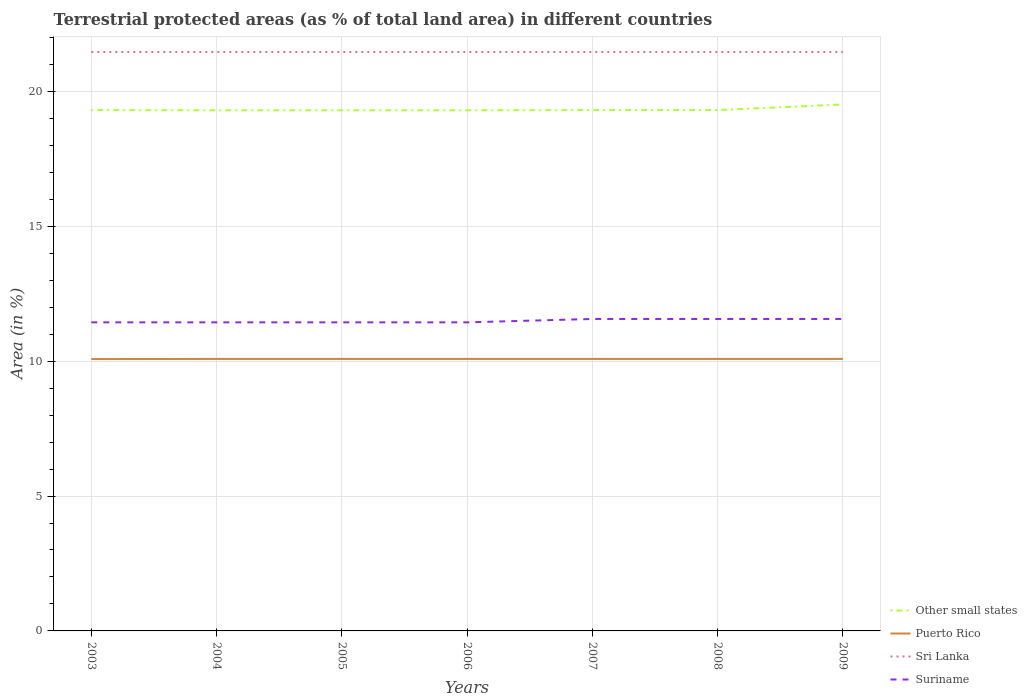How many different coloured lines are there?
Give a very brief answer. 4. Does the line corresponding to Sri Lanka intersect with the line corresponding to Other small states?
Make the answer very short. No. Across all years, what is the maximum percentage of terrestrial protected land in Suriname?
Your response must be concise. 11.44. What is the difference between the highest and the second highest percentage of terrestrial protected land in Sri Lanka?
Ensure brevity in your answer.  0. What is the difference between the highest and the lowest percentage of terrestrial protected land in Puerto Rico?
Offer a very short reply. 6. How many lines are there?
Ensure brevity in your answer.  4. What is the difference between two consecutive major ticks on the Y-axis?
Offer a very short reply. 5. Are the values on the major ticks of Y-axis written in scientific E-notation?
Ensure brevity in your answer.  No. How are the legend labels stacked?
Give a very brief answer. Vertical. What is the title of the graph?
Provide a succinct answer. Terrestrial protected areas (as % of total land area) in different countries. Does "Australia" appear as one of the legend labels in the graph?
Give a very brief answer. No. What is the label or title of the X-axis?
Offer a terse response. Years. What is the label or title of the Y-axis?
Offer a terse response. Area (in %). What is the Area (in %) of Other small states in 2003?
Your answer should be very brief. 19.31. What is the Area (in %) in Puerto Rico in 2003?
Ensure brevity in your answer.  10.08. What is the Area (in %) of Sri Lanka in 2003?
Give a very brief answer. 21.46. What is the Area (in %) in Suriname in 2003?
Provide a short and direct response. 11.44. What is the Area (in %) of Other small states in 2004?
Your answer should be very brief. 19.3. What is the Area (in %) in Puerto Rico in 2004?
Your answer should be compact. 10.08. What is the Area (in %) of Sri Lanka in 2004?
Offer a terse response. 21.46. What is the Area (in %) in Suriname in 2004?
Offer a terse response. 11.44. What is the Area (in %) in Other small states in 2005?
Offer a terse response. 19.3. What is the Area (in %) in Puerto Rico in 2005?
Your answer should be compact. 10.08. What is the Area (in %) of Sri Lanka in 2005?
Make the answer very short. 21.46. What is the Area (in %) of Suriname in 2005?
Your response must be concise. 11.44. What is the Area (in %) of Other small states in 2006?
Your answer should be very brief. 19.3. What is the Area (in %) of Puerto Rico in 2006?
Provide a succinct answer. 10.08. What is the Area (in %) of Sri Lanka in 2006?
Your response must be concise. 21.46. What is the Area (in %) in Suriname in 2006?
Your answer should be compact. 11.44. What is the Area (in %) in Other small states in 2007?
Your answer should be compact. 19.31. What is the Area (in %) of Puerto Rico in 2007?
Provide a short and direct response. 10.08. What is the Area (in %) in Sri Lanka in 2007?
Your answer should be very brief. 21.46. What is the Area (in %) of Suriname in 2007?
Provide a short and direct response. 11.56. What is the Area (in %) of Other small states in 2008?
Your response must be concise. 19.31. What is the Area (in %) of Puerto Rico in 2008?
Provide a short and direct response. 10.08. What is the Area (in %) of Sri Lanka in 2008?
Offer a terse response. 21.46. What is the Area (in %) of Suriname in 2008?
Provide a succinct answer. 11.56. What is the Area (in %) of Other small states in 2009?
Provide a short and direct response. 19.52. What is the Area (in %) of Puerto Rico in 2009?
Your answer should be compact. 10.08. What is the Area (in %) in Sri Lanka in 2009?
Give a very brief answer. 21.46. What is the Area (in %) in Suriname in 2009?
Offer a terse response. 11.56. Across all years, what is the maximum Area (in %) of Other small states?
Your answer should be compact. 19.52. Across all years, what is the maximum Area (in %) of Puerto Rico?
Your answer should be very brief. 10.08. Across all years, what is the maximum Area (in %) in Sri Lanka?
Keep it short and to the point. 21.46. Across all years, what is the maximum Area (in %) in Suriname?
Make the answer very short. 11.56. Across all years, what is the minimum Area (in %) of Other small states?
Your answer should be compact. 19.3. Across all years, what is the minimum Area (in %) of Puerto Rico?
Give a very brief answer. 10.08. Across all years, what is the minimum Area (in %) of Sri Lanka?
Your answer should be very brief. 21.46. Across all years, what is the minimum Area (in %) of Suriname?
Ensure brevity in your answer.  11.44. What is the total Area (in %) of Other small states in the graph?
Make the answer very short. 135.35. What is the total Area (in %) in Puerto Rico in the graph?
Your answer should be very brief. 70.58. What is the total Area (in %) in Sri Lanka in the graph?
Give a very brief answer. 150.25. What is the total Area (in %) in Suriname in the graph?
Provide a succinct answer. 80.45. What is the difference between the Area (in %) of Other small states in 2003 and that in 2004?
Keep it short and to the point. 0.01. What is the difference between the Area (in %) of Puerto Rico in 2003 and that in 2004?
Provide a succinct answer. -0.01. What is the difference between the Area (in %) in Other small states in 2003 and that in 2005?
Your answer should be very brief. 0.01. What is the difference between the Area (in %) of Puerto Rico in 2003 and that in 2005?
Ensure brevity in your answer.  -0.01. What is the difference between the Area (in %) in Sri Lanka in 2003 and that in 2005?
Provide a succinct answer. 0. What is the difference between the Area (in %) of Other small states in 2003 and that in 2006?
Your answer should be compact. 0.01. What is the difference between the Area (in %) in Puerto Rico in 2003 and that in 2006?
Ensure brevity in your answer.  -0.01. What is the difference between the Area (in %) in Suriname in 2003 and that in 2006?
Keep it short and to the point. 0. What is the difference between the Area (in %) of Other small states in 2003 and that in 2007?
Make the answer very short. 0. What is the difference between the Area (in %) of Puerto Rico in 2003 and that in 2007?
Offer a terse response. -0.01. What is the difference between the Area (in %) of Sri Lanka in 2003 and that in 2007?
Offer a terse response. 0. What is the difference between the Area (in %) of Suriname in 2003 and that in 2007?
Keep it short and to the point. -0.13. What is the difference between the Area (in %) of Other small states in 2003 and that in 2008?
Ensure brevity in your answer.  0. What is the difference between the Area (in %) in Puerto Rico in 2003 and that in 2008?
Offer a terse response. -0.01. What is the difference between the Area (in %) in Sri Lanka in 2003 and that in 2008?
Your answer should be very brief. 0. What is the difference between the Area (in %) of Suriname in 2003 and that in 2008?
Provide a succinct answer. -0.13. What is the difference between the Area (in %) in Other small states in 2003 and that in 2009?
Your response must be concise. -0.21. What is the difference between the Area (in %) in Puerto Rico in 2003 and that in 2009?
Offer a terse response. -0.01. What is the difference between the Area (in %) of Sri Lanka in 2003 and that in 2009?
Offer a very short reply. 0. What is the difference between the Area (in %) of Suriname in 2003 and that in 2009?
Offer a terse response. -0.13. What is the difference between the Area (in %) of Other small states in 2004 and that in 2005?
Ensure brevity in your answer.  -0. What is the difference between the Area (in %) in Sri Lanka in 2004 and that in 2005?
Provide a short and direct response. 0. What is the difference between the Area (in %) of Other small states in 2004 and that in 2006?
Provide a succinct answer. -0. What is the difference between the Area (in %) of Puerto Rico in 2004 and that in 2006?
Your answer should be compact. 0. What is the difference between the Area (in %) in Other small states in 2004 and that in 2007?
Make the answer very short. -0.01. What is the difference between the Area (in %) of Puerto Rico in 2004 and that in 2007?
Your response must be concise. 0. What is the difference between the Area (in %) in Sri Lanka in 2004 and that in 2007?
Provide a succinct answer. 0. What is the difference between the Area (in %) of Suriname in 2004 and that in 2007?
Make the answer very short. -0.13. What is the difference between the Area (in %) in Other small states in 2004 and that in 2008?
Offer a very short reply. -0.01. What is the difference between the Area (in %) in Puerto Rico in 2004 and that in 2008?
Your answer should be compact. 0. What is the difference between the Area (in %) in Sri Lanka in 2004 and that in 2008?
Your answer should be compact. 0. What is the difference between the Area (in %) of Suriname in 2004 and that in 2008?
Make the answer very short. -0.13. What is the difference between the Area (in %) in Other small states in 2004 and that in 2009?
Your answer should be compact. -0.22. What is the difference between the Area (in %) of Suriname in 2004 and that in 2009?
Offer a very short reply. -0.13. What is the difference between the Area (in %) in Other small states in 2005 and that in 2006?
Your answer should be very brief. -0. What is the difference between the Area (in %) of Other small states in 2005 and that in 2007?
Your answer should be compact. -0.01. What is the difference between the Area (in %) in Suriname in 2005 and that in 2007?
Provide a short and direct response. -0.13. What is the difference between the Area (in %) in Other small states in 2005 and that in 2008?
Your answer should be compact. -0.01. What is the difference between the Area (in %) of Puerto Rico in 2005 and that in 2008?
Offer a terse response. 0. What is the difference between the Area (in %) in Suriname in 2005 and that in 2008?
Offer a terse response. -0.13. What is the difference between the Area (in %) in Other small states in 2005 and that in 2009?
Ensure brevity in your answer.  -0.22. What is the difference between the Area (in %) in Puerto Rico in 2005 and that in 2009?
Your answer should be very brief. 0. What is the difference between the Area (in %) in Suriname in 2005 and that in 2009?
Ensure brevity in your answer.  -0.13. What is the difference between the Area (in %) in Other small states in 2006 and that in 2007?
Your answer should be compact. -0.01. What is the difference between the Area (in %) in Puerto Rico in 2006 and that in 2007?
Ensure brevity in your answer.  0. What is the difference between the Area (in %) of Suriname in 2006 and that in 2007?
Ensure brevity in your answer.  -0.13. What is the difference between the Area (in %) of Other small states in 2006 and that in 2008?
Ensure brevity in your answer.  -0.01. What is the difference between the Area (in %) of Sri Lanka in 2006 and that in 2008?
Your response must be concise. 0. What is the difference between the Area (in %) of Suriname in 2006 and that in 2008?
Your answer should be compact. -0.13. What is the difference between the Area (in %) of Other small states in 2006 and that in 2009?
Your answer should be very brief. -0.22. What is the difference between the Area (in %) of Sri Lanka in 2006 and that in 2009?
Make the answer very short. 0. What is the difference between the Area (in %) in Suriname in 2006 and that in 2009?
Provide a short and direct response. -0.13. What is the difference between the Area (in %) of Puerto Rico in 2007 and that in 2008?
Provide a short and direct response. 0. What is the difference between the Area (in %) in Sri Lanka in 2007 and that in 2008?
Offer a very short reply. 0. What is the difference between the Area (in %) of Suriname in 2007 and that in 2008?
Give a very brief answer. 0. What is the difference between the Area (in %) of Other small states in 2007 and that in 2009?
Keep it short and to the point. -0.21. What is the difference between the Area (in %) in Puerto Rico in 2007 and that in 2009?
Keep it short and to the point. 0. What is the difference between the Area (in %) of Sri Lanka in 2007 and that in 2009?
Provide a succinct answer. 0. What is the difference between the Area (in %) in Suriname in 2007 and that in 2009?
Your response must be concise. 0. What is the difference between the Area (in %) of Other small states in 2008 and that in 2009?
Offer a very short reply. -0.21. What is the difference between the Area (in %) in Sri Lanka in 2008 and that in 2009?
Keep it short and to the point. 0. What is the difference between the Area (in %) in Suriname in 2008 and that in 2009?
Provide a short and direct response. 0. What is the difference between the Area (in %) of Other small states in 2003 and the Area (in %) of Puerto Rico in 2004?
Provide a short and direct response. 9.23. What is the difference between the Area (in %) of Other small states in 2003 and the Area (in %) of Sri Lanka in 2004?
Make the answer very short. -2.16. What is the difference between the Area (in %) in Other small states in 2003 and the Area (in %) in Suriname in 2004?
Your response must be concise. 7.87. What is the difference between the Area (in %) in Puerto Rico in 2003 and the Area (in %) in Sri Lanka in 2004?
Ensure brevity in your answer.  -11.39. What is the difference between the Area (in %) in Puerto Rico in 2003 and the Area (in %) in Suriname in 2004?
Offer a terse response. -1.36. What is the difference between the Area (in %) in Sri Lanka in 2003 and the Area (in %) in Suriname in 2004?
Your answer should be compact. 10.02. What is the difference between the Area (in %) in Other small states in 2003 and the Area (in %) in Puerto Rico in 2005?
Your answer should be compact. 9.23. What is the difference between the Area (in %) of Other small states in 2003 and the Area (in %) of Sri Lanka in 2005?
Give a very brief answer. -2.16. What is the difference between the Area (in %) in Other small states in 2003 and the Area (in %) in Suriname in 2005?
Your answer should be very brief. 7.87. What is the difference between the Area (in %) of Puerto Rico in 2003 and the Area (in %) of Sri Lanka in 2005?
Make the answer very short. -11.39. What is the difference between the Area (in %) of Puerto Rico in 2003 and the Area (in %) of Suriname in 2005?
Keep it short and to the point. -1.36. What is the difference between the Area (in %) of Sri Lanka in 2003 and the Area (in %) of Suriname in 2005?
Provide a short and direct response. 10.02. What is the difference between the Area (in %) in Other small states in 2003 and the Area (in %) in Puerto Rico in 2006?
Offer a very short reply. 9.23. What is the difference between the Area (in %) of Other small states in 2003 and the Area (in %) of Sri Lanka in 2006?
Offer a very short reply. -2.16. What is the difference between the Area (in %) of Other small states in 2003 and the Area (in %) of Suriname in 2006?
Ensure brevity in your answer.  7.87. What is the difference between the Area (in %) of Puerto Rico in 2003 and the Area (in %) of Sri Lanka in 2006?
Offer a terse response. -11.39. What is the difference between the Area (in %) of Puerto Rico in 2003 and the Area (in %) of Suriname in 2006?
Your answer should be compact. -1.36. What is the difference between the Area (in %) of Sri Lanka in 2003 and the Area (in %) of Suriname in 2006?
Provide a short and direct response. 10.02. What is the difference between the Area (in %) in Other small states in 2003 and the Area (in %) in Puerto Rico in 2007?
Offer a very short reply. 9.23. What is the difference between the Area (in %) in Other small states in 2003 and the Area (in %) in Sri Lanka in 2007?
Give a very brief answer. -2.16. What is the difference between the Area (in %) in Other small states in 2003 and the Area (in %) in Suriname in 2007?
Keep it short and to the point. 7.74. What is the difference between the Area (in %) of Puerto Rico in 2003 and the Area (in %) of Sri Lanka in 2007?
Your response must be concise. -11.39. What is the difference between the Area (in %) of Puerto Rico in 2003 and the Area (in %) of Suriname in 2007?
Ensure brevity in your answer.  -1.49. What is the difference between the Area (in %) in Sri Lanka in 2003 and the Area (in %) in Suriname in 2007?
Your answer should be compact. 9.9. What is the difference between the Area (in %) of Other small states in 2003 and the Area (in %) of Puerto Rico in 2008?
Keep it short and to the point. 9.23. What is the difference between the Area (in %) in Other small states in 2003 and the Area (in %) in Sri Lanka in 2008?
Offer a terse response. -2.16. What is the difference between the Area (in %) of Other small states in 2003 and the Area (in %) of Suriname in 2008?
Your answer should be very brief. 7.74. What is the difference between the Area (in %) of Puerto Rico in 2003 and the Area (in %) of Sri Lanka in 2008?
Your answer should be compact. -11.39. What is the difference between the Area (in %) in Puerto Rico in 2003 and the Area (in %) in Suriname in 2008?
Offer a very short reply. -1.49. What is the difference between the Area (in %) of Sri Lanka in 2003 and the Area (in %) of Suriname in 2008?
Your response must be concise. 9.9. What is the difference between the Area (in %) of Other small states in 2003 and the Area (in %) of Puerto Rico in 2009?
Your response must be concise. 9.23. What is the difference between the Area (in %) of Other small states in 2003 and the Area (in %) of Sri Lanka in 2009?
Ensure brevity in your answer.  -2.16. What is the difference between the Area (in %) in Other small states in 2003 and the Area (in %) in Suriname in 2009?
Offer a terse response. 7.74. What is the difference between the Area (in %) of Puerto Rico in 2003 and the Area (in %) of Sri Lanka in 2009?
Offer a terse response. -11.39. What is the difference between the Area (in %) in Puerto Rico in 2003 and the Area (in %) in Suriname in 2009?
Your answer should be compact. -1.49. What is the difference between the Area (in %) in Sri Lanka in 2003 and the Area (in %) in Suriname in 2009?
Offer a terse response. 9.9. What is the difference between the Area (in %) in Other small states in 2004 and the Area (in %) in Puerto Rico in 2005?
Your response must be concise. 9.22. What is the difference between the Area (in %) of Other small states in 2004 and the Area (in %) of Sri Lanka in 2005?
Offer a very short reply. -2.16. What is the difference between the Area (in %) of Other small states in 2004 and the Area (in %) of Suriname in 2005?
Your response must be concise. 7.86. What is the difference between the Area (in %) of Puerto Rico in 2004 and the Area (in %) of Sri Lanka in 2005?
Your answer should be compact. -11.38. What is the difference between the Area (in %) of Puerto Rico in 2004 and the Area (in %) of Suriname in 2005?
Your answer should be very brief. -1.36. What is the difference between the Area (in %) in Sri Lanka in 2004 and the Area (in %) in Suriname in 2005?
Offer a very short reply. 10.02. What is the difference between the Area (in %) of Other small states in 2004 and the Area (in %) of Puerto Rico in 2006?
Ensure brevity in your answer.  9.22. What is the difference between the Area (in %) of Other small states in 2004 and the Area (in %) of Sri Lanka in 2006?
Your response must be concise. -2.16. What is the difference between the Area (in %) of Other small states in 2004 and the Area (in %) of Suriname in 2006?
Your response must be concise. 7.86. What is the difference between the Area (in %) in Puerto Rico in 2004 and the Area (in %) in Sri Lanka in 2006?
Provide a succinct answer. -11.38. What is the difference between the Area (in %) of Puerto Rico in 2004 and the Area (in %) of Suriname in 2006?
Make the answer very short. -1.36. What is the difference between the Area (in %) of Sri Lanka in 2004 and the Area (in %) of Suriname in 2006?
Offer a very short reply. 10.02. What is the difference between the Area (in %) in Other small states in 2004 and the Area (in %) in Puerto Rico in 2007?
Your response must be concise. 9.22. What is the difference between the Area (in %) of Other small states in 2004 and the Area (in %) of Sri Lanka in 2007?
Your answer should be very brief. -2.16. What is the difference between the Area (in %) in Other small states in 2004 and the Area (in %) in Suriname in 2007?
Provide a short and direct response. 7.74. What is the difference between the Area (in %) of Puerto Rico in 2004 and the Area (in %) of Sri Lanka in 2007?
Offer a terse response. -11.38. What is the difference between the Area (in %) in Puerto Rico in 2004 and the Area (in %) in Suriname in 2007?
Provide a short and direct response. -1.48. What is the difference between the Area (in %) of Sri Lanka in 2004 and the Area (in %) of Suriname in 2007?
Your response must be concise. 9.9. What is the difference between the Area (in %) in Other small states in 2004 and the Area (in %) in Puerto Rico in 2008?
Your answer should be compact. 9.22. What is the difference between the Area (in %) of Other small states in 2004 and the Area (in %) of Sri Lanka in 2008?
Give a very brief answer. -2.16. What is the difference between the Area (in %) in Other small states in 2004 and the Area (in %) in Suriname in 2008?
Provide a succinct answer. 7.74. What is the difference between the Area (in %) of Puerto Rico in 2004 and the Area (in %) of Sri Lanka in 2008?
Make the answer very short. -11.38. What is the difference between the Area (in %) in Puerto Rico in 2004 and the Area (in %) in Suriname in 2008?
Offer a terse response. -1.48. What is the difference between the Area (in %) of Sri Lanka in 2004 and the Area (in %) of Suriname in 2008?
Ensure brevity in your answer.  9.9. What is the difference between the Area (in %) in Other small states in 2004 and the Area (in %) in Puerto Rico in 2009?
Your answer should be very brief. 9.22. What is the difference between the Area (in %) in Other small states in 2004 and the Area (in %) in Sri Lanka in 2009?
Your answer should be very brief. -2.16. What is the difference between the Area (in %) of Other small states in 2004 and the Area (in %) of Suriname in 2009?
Give a very brief answer. 7.74. What is the difference between the Area (in %) in Puerto Rico in 2004 and the Area (in %) in Sri Lanka in 2009?
Your response must be concise. -11.38. What is the difference between the Area (in %) of Puerto Rico in 2004 and the Area (in %) of Suriname in 2009?
Offer a very short reply. -1.48. What is the difference between the Area (in %) in Sri Lanka in 2004 and the Area (in %) in Suriname in 2009?
Provide a succinct answer. 9.9. What is the difference between the Area (in %) of Other small states in 2005 and the Area (in %) of Puerto Rico in 2006?
Your answer should be compact. 9.22. What is the difference between the Area (in %) of Other small states in 2005 and the Area (in %) of Sri Lanka in 2006?
Provide a short and direct response. -2.16. What is the difference between the Area (in %) of Other small states in 2005 and the Area (in %) of Suriname in 2006?
Provide a succinct answer. 7.86. What is the difference between the Area (in %) of Puerto Rico in 2005 and the Area (in %) of Sri Lanka in 2006?
Give a very brief answer. -11.38. What is the difference between the Area (in %) of Puerto Rico in 2005 and the Area (in %) of Suriname in 2006?
Offer a terse response. -1.36. What is the difference between the Area (in %) of Sri Lanka in 2005 and the Area (in %) of Suriname in 2006?
Offer a very short reply. 10.02. What is the difference between the Area (in %) in Other small states in 2005 and the Area (in %) in Puerto Rico in 2007?
Your answer should be very brief. 9.22. What is the difference between the Area (in %) of Other small states in 2005 and the Area (in %) of Sri Lanka in 2007?
Make the answer very short. -2.16. What is the difference between the Area (in %) of Other small states in 2005 and the Area (in %) of Suriname in 2007?
Make the answer very short. 7.74. What is the difference between the Area (in %) in Puerto Rico in 2005 and the Area (in %) in Sri Lanka in 2007?
Make the answer very short. -11.38. What is the difference between the Area (in %) of Puerto Rico in 2005 and the Area (in %) of Suriname in 2007?
Make the answer very short. -1.48. What is the difference between the Area (in %) of Sri Lanka in 2005 and the Area (in %) of Suriname in 2007?
Ensure brevity in your answer.  9.9. What is the difference between the Area (in %) of Other small states in 2005 and the Area (in %) of Puerto Rico in 2008?
Your response must be concise. 9.22. What is the difference between the Area (in %) of Other small states in 2005 and the Area (in %) of Sri Lanka in 2008?
Ensure brevity in your answer.  -2.16. What is the difference between the Area (in %) of Other small states in 2005 and the Area (in %) of Suriname in 2008?
Offer a terse response. 7.74. What is the difference between the Area (in %) of Puerto Rico in 2005 and the Area (in %) of Sri Lanka in 2008?
Give a very brief answer. -11.38. What is the difference between the Area (in %) of Puerto Rico in 2005 and the Area (in %) of Suriname in 2008?
Your answer should be compact. -1.48. What is the difference between the Area (in %) of Sri Lanka in 2005 and the Area (in %) of Suriname in 2008?
Your answer should be very brief. 9.9. What is the difference between the Area (in %) in Other small states in 2005 and the Area (in %) in Puerto Rico in 2009?
Make the answer very short. 9.22. What is the difference between the Area (in %) in Other small states in 2005 and the Area (in %) in Sri Lanka in 2009?
Provide a succinct answer. -2.16. What is the difference between the Area (in %) of Other small states in 2005 and the Area (in %) of Suriname in 2009?
Make the answer very short. 7.74. What is the difference between the Area (in %) of Puerto Rico in 2005 and the Area (in %) of Sri Lanka in 2009?
Keep it short and to the point. -11.38. What is the difference between the Area (in %) of Puerto Rico in 2005 and the Area (in %) of Suriname in 2009?
Your response must be concise. -1.48. What is the difference between the Area (in %) of Sri Lanka in 2005 and the Area (in %) of Suriname in 2009?
Provide a succinct answer. 9.9. What is the difference between the Area (in %) in Other small states in 2006 and the Area (in %) in Puerto Rico in 2007?
Ensure brevity in your answer.  9.22. What is the difference between the Area (in %) in Other small states in 2006 and the Area (in %) in Sri Lanka in 2007?
Your answer should be compact. -2.16. What is the difference between the Area (in %) in Other small states in 2006 and the Area (in %) in Suriname in 2007?
Give a very brief answer. 7.74. What is the difference between the Area (in %) of Puerto Rico in 2006 and the Area (in %) of Sri Lanka in 2007?
Give a very brief answer. -11.38. What is the difference between the Area (in %) in Puerto Rico in 2006 and the Area (in %) in Suriname in 2007?
Ensure brevity in your answer.  -1.48. What is the difference between the Area (in %) of Sri Lanka in 2006 and the Area (in %) of Suriname in 2007?
Keep it short and to the point. 9.9. What is the difference between the Area (in %) in Other small states in 2006 and the Area (in %) in Puerto Rico in 2008?
Your answer should be very brief. 9.22. What is the difference between the Area (in %) in Other small states in 2006 and the Area (in %) in Sri Lanka in 2008?
Make the answer very short. -2.16. What is the difference between the Area (in %) of Other small states in 2006 and the Area (in %) of Suriname in 2008?
Make the answer very short. 7.74. What is the difference between the Area (in %) in Puerto Rico in 2006 and the Area (in %) in Sri Lanka in 2008?
Your response must be concise. -11.38. What is the difference between the Area (in %) of Puerto Rico in 2006 and the Area (in %) of Suriname in 2008?
Give a very brief answer. -1.48. What is the difference between the Area (in %) in Sri Lanka in 2006 and the Area (in %) in Suriname in 2008?
Offer a terse response. 9.9. What is the difference between the Area (in %) of Other small states in 2006 and the Area (in %) of Puerto Rico in 2009?
Keep it short and to the point. 9.22. What is the difference between the Area (in %) of Other small states in 2006 and the Area (in %) of Sri Lanka in 2009?
Your answer should be very brief. -2.16. What is the difference between the Area (in %) of Other small states in 2006 and the Area (in %) of Suriname in 2009?
Provide a short and direct response. 7.74. What is the difference between the Area (in %) in Puerto Rico in 2006 and the Area (in %) in Sri Lanka in 2009?
Your response must be concise. -11.38. What is the difference between the Area (in %) of Puerto Rico in 2006 and the Area (in %) of Suriname in 2009?
Your answer should be very brief. -1.48. What is the difference between the Area (in %) of Sri Lanka in 2006 and the Area (in %) of Suriname in 2009?
Ensure brevity in your answer.  9.9. What is the difference between the Area (in %) of Other small states in 2007 and the Area (in %) of Puerto Rico in 2008?
Ensure brevity in your answer.  9.22. What is the difference between the Area (in %) in Other small states in 2007 and the Area (in %) in Sri Lanka in 2008?
Provide a succinct answer. -2.16. What is the difference between the Area (in %) in Other small states in 2007 and the Area (in %) in Suriname in 2008?
Your answer should be compact. 7.74. What is the difference between the Area (in %) of Puerto Rico in 2007 and the Area (in %) of Sri Lanka in 2008?
Your answer should be very brief. -11.38. What is the difference between the Area (in %) of Puerto Rico in 2007 and the Area (in %) of Suriname in 2008?
Give a very brief answer. -1.48. What is the difference between the Area (in %) in Sri Lanka in 2007 and the Area (in %) in Suriname in 2008?
Offer a very short reply. 9.9. What is the difference between the Area (in %) in Other small states in 2007 and the Area (in %) in Puerto Rico in 2009?
Offer a very short reply. 9.22. What is the difference between the Area (in %) in Other small states in 2007 and the Area (in %) in Sri Lanka in 2009?
Offer a very short reply. -2.16. What is the difference between the Area (in %) of Other small states in 2007 and the Area (in %) of Suriname in 2009?
Give a very brief answer. 7.74. What is the difference between the Area (in %) in Puerto Rico in 2007 and the Area (in %) in Sri Lanka in 2009?
Provide a succinct answer. -11.38. What is the difference between the Area (in %) in Puerto Rico in 2007 and the Area (in %) in Suriname in 2009?
Make the answer very short. -1.48. What is the difference between the Area (in %) of Sri Lanka in 2007 and the Area (in %) of Suriname in 2009?
Ensure brevity in your answer.  9.9. What is the difference between the Area (in %) of Other small states in 2008 and the Area (in %) of Puerto Rico in 2009?
Keep it short and to the point. 9.22. What is the difference between the Area (in %) in Other small states in 2008 and the Area (in %) in Sri Lanka in 2009?
Your response must be concise. -2.16. What is the difference between the Area (in %) in Other small states in 2008 and the Area (in %) in Suriname in 2009?
Your answer should be very brief. 7.74. What is the difference between the Area (in %) in Puerto Rico in 2008 and the Area (in %) in Sri Lanka in 2009?
Provide a short and direct response. -11.38. What is the difference between the Area (in %) of Puerto Rico in 2008 and the Area (in %) of Suriname in 2009?
Offer a very short reply. -1.48. What is the difference between the Area (in %) of Sri Lanka in 2008 and the Area (in %) of Suriname in 2009?
Ensure brevity in your answer.  9.9. What is the average Area (in %) of Other small states per year?
Keep it short and to the point. 19.34. What is the average Area (in %) in Puerto Rico per year?
Make the answer very short. 10.08. What is the average Area (in %) of Sri Lanka per year?
Keep it short and to the point. 21.46. What is the average Area (in %) of Suriname per year?
Make the answer very short. 11.49. In the year 2003, what is the difference between the Area (in %) in Other small states and Area (in %) in Puerto Rico?
Provide a short and direct response. 9.23. In the year 2003, what is the difference between the Area (in %) in Other small states and Area (in %) in Sri Lanka?
Your answer should be compact. -2.16. In the year 2003, what is the difference between the Area (in %) in Other small states and Area (in %) in Suriname?
Ensure brevity in your answer.  7.87. In the year 2003, what is the difference between the Area (in %) of Puerto Rico and Area (in %) of Sri Lanka?
Offer a very short reply. -11.39. In the year 2003, what is the difference between the Area (in %) of Puerto Rico and Area (in %) of Suriname?
Your response must be concise. -1.36. In the year 2003, what is the difference between the Area (in %) in Sri Lanka and Area (in %) in Suriname?
Make the answer very short. 10.02. In the year 2004, what is the difference between the Area (in %) of Other small states and Area (in %) of Puerto Rico?
Your answer should be very brief. 9.22. In the year 2004, what is the difference between the Area (in %) in Other small states and Area (in %) in Sri Lanka?
Offer a terse response. -2.16. In the year 2004, what is the difference between the Area (in %) in Other small states and Area (in %) in Suriname?
Your answer should be compact. 7.86. In the year 2004, what is the difference between the Area (in %) of Puerto Rico and Area (in %) of Sri Lanka?
Give a very brief answer. -11.38. In the year 2004, what is the difference between the Area (in %) in Puerto Rico and Area (in %) in Suriname?
Ensure brevity in your answer.  -1.36. In the year 2004, what is the difference between the Area (in %) in Sri Lanka and Area (in %) in Suriname?
Your response must be concise. 10.02. In the year 2005, what is the difference between the Area (in %) of Other small states and Area (in %) of Puerto Rico?
Your response must be concise. 9.22. In the year 2005, what is the difference between the Area (in %) of Other small states and Area (in %) of Sri Lanka?
Provide a short and direct response. -2.16. In the year 2005, what is the difference between the Area (in %) of Other small states and Area (in %) of Suriname?
Keep it short and to the point. 7.86. In the year 2005, what is the difference between the Area (in %) in Puerto Rico and Area (in %) in Sri Lanka?
Your answer should be compact. -11.38. In the year 2005, what is the difference between the Area (in %) in Puerto Rico and Area (in %) in Suriname?
Give a very brief answer. -1.36. In the year 2005, what is the difference between the Area (in %) of Sri Lanka and Area (in %) of Suriname?
Your answer should be very brief. 10.02. In the year 2006, what is the difference between the Area (in %) in Other small states and Area (in %) in Puerto Rico?
Your answer should be very brief. 9.22. In the year 2006, what is the difference between the Area (in %) of Other small states and Area (in %) of Sri Lanka?
Offer a terse response. -2.16. In the year 2006, what is the difference between the Area (in %) in Other small states and Area (in %) in Suriname?
Offer a terse response. 7.86. In the year 2006, what is the difference between the Area (in %) in Puerto Rico and Area (in %) in Sri Lanka?
Ensure brevity in your answer.  -11.38. In the year 2006, what is the difference between the Area (in %) of Puerto Rico and Area (in %) of Suriname?
Ensure brevity in your answer.  -1.36. In the year 2006, what is the difference between the Area (in %) in Sri Lanka and Area (in %) in Suriname?
Ensure brevity in your answer.  10.02. In the year 2007, what is the difference between the Area (in %) of Other small states and Area (in %) of Puerto Rico?
Provide a short and direct response. 9.22. In the year 2007, what is the difference between the Area (in %) in Other small states and Area (in %) in Sri Lanka?
Provide a short and direct response. -2.16. In the year 2007, what is the difference between the Area (in %) of Other small states and Area (in %) of Suriname?
Make the answer very short. 7.74. In the year 2007, what is the difference between the Area (in %) of Puerto Rico and Area (in %) of Sri Lanka?
Ensure brevity in your answer.  -11.38. In the year 2007, what is the difference between the Area (in %) in Puerto Rico and Area (in %) in Suriname?
Your answer should be very brief. -1.48. In the year 2007, what is the difference between the Area (in %) of Sri Lanka and Area (in %) of Suriname?
Offer a terse response. 9.9. In the year 2008, what is the difference between the Area (in %) in Other small states and Area (in %) in Puerto Rico?
Keep it short and to the point. 9.22. In the year 2008, what is the difference between the Area (in %) in Other small states and Area (in %) in Sri Lanka?
Provide a succinct answer. -2.16. In the year 2008, what is the difference between the Area (in %) of Other small states and Area (in %) of Suriname?
Ensure brevity in your answer.  7.74. In the year 2008, what is the difference between the Area (in %) in Puerto Rico and Area (in %) in Sri Lanka?
Your answer should be compact. -11.38. In the year 2008, what is the difference between the Area (in %) in Puerto Rico and Area (in %) in Suriname?
Provide a short and direct response. -1.48. In the year 2008, what is the difference between the Area (in %) of Sri Lanka and Area (in %) of Suriname?
Make the answer very short. 9.9. In the year 2009, what is the difference between the Area (in %) of Other small states and Area (in %) of Puerto Rico?
Provide a short and direct response. 9.43. In the year 2009, what is the difference between the Area (in %) of Other small states and Area (in %) of Sri Lanka?
Offer a very short reply. -1.95. In the year 2009, what is the difference between the Area (in %) of Other small states and Area (in %) of Suriname?
Your response must be concise. 7.95. In the year 2009, what is the difference between the Area (in %) in Puerto Rico and Area (in %) in Sri Lanka?
Ensure brevity in your answer.  -11.38. In the year 2009, what is the difference between the Area (in %) in Puerto Rico and Area (in %) in Suriname?
Offer a terse response. -1.48. In the year 2009, what is the difference between the Area (in %) in Sri Lanka and Area (in %) in Suriname?
Your response must be concise. 9.9. What is the ratio of the Area (in %) of Other small states in 2003 to that in 2004?
Your answer should be very brief. 1. What is the ratio of the Area (in %) in Puerto Rico in 2003 to that in 2004?
Provide a succinct answer. 1. What is the ratio of the Area (in %) of Suriname in 2003 to that in 2005?
Offer a terse response. 1. What is the ratio of the Area (in %) of Other small states in 2003 to that in 2006?
Offer a terse response. 1. What is the ratio of the Area (in %) in Puerto Rico in 2003 to that in 2006?
Give a very brief answer. 1. What is the ratio of the Area (in %) in Sri Lanka in 2003 to that in 2006?
Offer a very short reply. 1. What is the ratio of the Area (in %) of Suriname in 2003 to that in 2006?
Offer a terse response. 1. What is the ratio of the Area (in %) in Other small states in 2003 to that in 2007?
Give a very brief answer. 1. What is the ratio of the Area (in %) of Puerto Rico in 2003 to that in 2007?
Your response must be concise. 1. What is the ratio of the Area (in %) of Suriname in 2003 to that in 2007?
Your answer should be very brief. 0.99. What is the ratio of the Area (in %) of Puerto Rico in 2003 to that in 2008?
Your response must be concise. 1. What is the ratio of the Area (in %) in Sri Lanka in 2003 to that in 2008?
Keep it short and to the point. 1. What is the ratio of the Area (in %) of Other small states in 2003 to that in 2009?
Give a very brief answer. 0.99. What is the ratio of the Area (in %) in Puerto Rico in 2004 to that in 2005?
Give a very brief answer. 1. What is the ratio of the Area (in %) in Sri Lanka in 2004 to that in 2005?
Keep it short and to the point. 1. What is the ratio of the Area (in %) in Puerto Rico in 2004 to that in 2006?
Keep it short and to the point. 1. What is the ratio of the Area (in %) of Sri Lanka in 2004 to that in 2006?
Provide a short and direct response. 1. What is the ratio of the Area (in %) in Sri Lanka in 2004 to that in 2007?
Your answer should be very brief. 1. What is the ratio of the Area (in %) of Suriname in 2004 to that in 2007?
Give a very brief answer. 0.99. What is the ratio of the Area (in %) of Puerto Rico in 2004 to that in 2008?
Keep it short and to the point. 1. What is the ratio of the Area (in %) in Other small states in 2004 to that in 2009?
Provide a succinct answer. 0.99. What is the ratio of the Area (in %) of Puerto Rico in 2004 to that in 2009?
Give a very brief answer. 1. What is the ratio of the Area (in %) of Suriname in 2004 to that in 2009?
Your response must be concise. 0.99. What is the ratio of the Area (in %) in Other small states in 2005 to that in 2006?
Provide a succinct answer. 1. What is the ratio of the Area (in %) in Puerto Rico in 2005 to that in 2006?
Ensure brevity in your answer.  1. What is the ratio of the Area (in %) in Sri Lanka in 2005 to that in 2006?
Provide a succinct answer. 1. What is the ratio of the Area (in %) in Puerto Rico in 2005 to that in 2007?
Provide a succinct answer. 1. What is the ratio of the Area (in %) in Sri Lanka in 2005 to that in 2007?
Offer a terse response. 1. What is the ratio of the Area (in %) in Other small states in 2005 to that in 2008?
Keep it short and to the point. 1. What is the ratio of the Area (in %) in Puerto Rico in 2005 to that in 2008?
Provide a short and direct response. 1. What is the ratio of the Area (in %) in Other small states in 2005 to that in 2009?
Provide a succinct answer. 0.99. What is the ratio of the Area (in %) in Suriname in 2005 to that in 2009?
Ensure brevity in your answer.  0.99. What is the ratio of the Area (in %) in Other small states in 2006 to that in 2007?
Offer a very short reply. 1. What is the ratio of the Area (in %) in Puerto Rico in 2006 to that in 2007?
Provide a succinct answer. 1. What is the ratio of the Area (in %) in Sri Lanka in 2006 to that in 2007?
Make the answer very short. 1. What is the ratio of the Area (in %) in Suriname in 2006 to that in 2007?
Your answer should be compact. 0.99. What is the ratio of the Area (in %) in Other small states in 2006 to that in 2008?
Offer a terse response. 1. What is the ratio of the Area (in %) of Other small states in 2006 to that in 2009?
Your response must be concise. 0.99. What is the ratio of the Area (in %) of Puerto Rico in 2006 to that in 2009?
Offer a very short reply. 1. What is the ratio of the Area (in %) of Sri Lanka in 2006 to that in 2009?
Your response must be concise. 1. What is the ratio of the Area (in %) in Suriname in 2006 to that in 2009?
Make the answer very short. 0.99. What is the ratio of the Area (in %) in Suriname in 2007 to that in 2008?
Your response must be concise. 1. What is the ratio of the Area (in %) of Other small states in 2007 to that in 2009?
Your answer should be very brief. 0.99. What is the ratio of the Area (in %) in Puerto Rico in 2007 to that in 2009?
Keep it short and to the point. 1. What is the ratio of the Area (in %) of Sri Lanka in 2007 to that in 2009?
Offer a terse response. 1. What is the ratio of the Area (in %) of Suriname in 2007 to that in 2009?
Make the answer very short. 1. What is the ratio of the Area (in %) in Suriname in 2008 to that in 2009?
Provide a short and direct response. 1. What is the difference between the highest and the second highest Area (in %) in Other small states?
Provide a short and direct response. 0.21. What is the difference between the highest and the second highest Area (in %) of Puerto Rico?
Your answer should be compact. 0. What is the difference between the highest and the second highest Area (in %) of Suriname?
Your answer should be very brief. 0. What is the difference between the highest and the lowest Area (in %) in Other small states?
Provide a succinct answer. 0.22. What is the difference between the highest and the lowest Area (in %) in Puerto Rico?
Ensure brevity in your answer.  0.01. What is the difference between the highest and the lowest Area (in %) in Sri Lanka?
Make the answer very short. 0. What is the difference between the highest and the lowest Area (in %) of Suriname?
Ensure brevity in your answer.  0.13. 